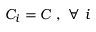Convert formula to latex. <formula><loc_0><loc_0><loc_500><loc_500>C _ { i } = C , \forall i</formula> 